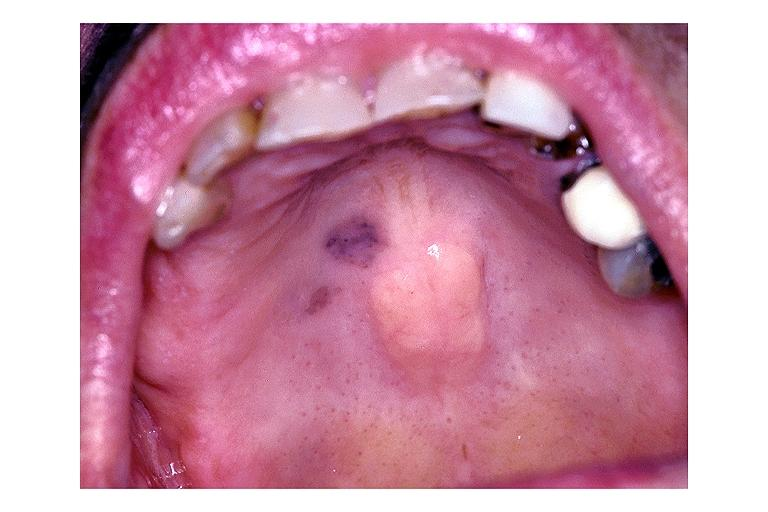what does this image show?
Answer the question using a single word or phrase. Focal melanosis 